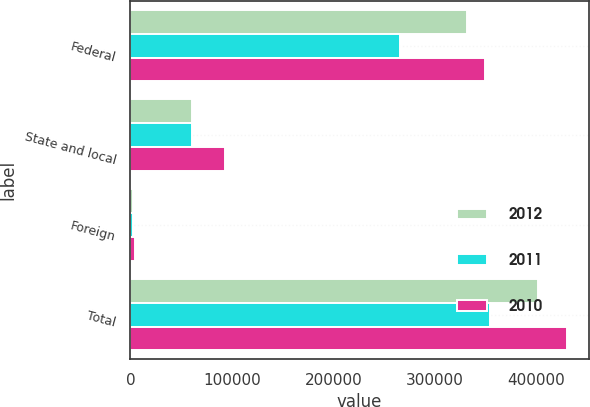Convert chart. <chart><loc_0><loc_0><loc_500><loc_500><stacked_bar_chart><ecel><fcel>Federal<fcel>State and local<fcel>Foreign<fcel>Total<nl><fcel>2012<fcel>332053<fcel>60708<fcel>2649<fcel>401897<nl><fcel>2011<fcel>265865<fcel>60273<fcel>2666<fcel>354702<nl><fcel>2010<fcel>349755<fcel>93229<fcel>4283<fcel>430127<nl></chart> 